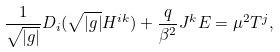<formula> <loc_0><loc_0><loc_500><loc_500>\frac { 1 } { \sqrt { | g | } } D _ { i } ( \sqrt { | g | } H ^ { i k } ) + \frac { q } { \beta ^ { 2 } } J ^ { k } E = \mu ^ { 2 } T ^ { j } ,</formula> 